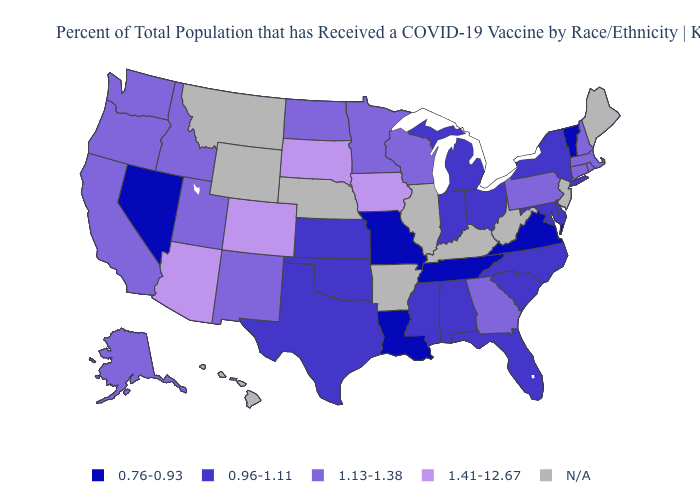Name the states that have a value in the range 1.13-1.38?
Write a very short answer. Alaska, California, Connecticut, Georgia, Idaho, Massachusetts, Minnesota, New Hampshire, New Mexico, North Dakota, Oregon, Pennsylvania, Rhode Island, Utah, Washington, Wisconsin. What is the value of New York?
Keep it brief. 0.96-1.11. Among the states that border South Dakota , which have the lowest value?
Short answer required. Minnesota, North Dakota. Name the states that have a value in the range N/A?
Be succinct. Arkansas, Hawaii, Illinois, Kentucky, Maine, Montana, Nebraska, New Jersey, West Virginia, Wyoming. What is the value of Wyoming?
Quick response, please. N/A. What is the lowest value in states that border West Virginia?
Answer briefly. 0.76-0.93. Among the states that border Tennessee , does Mississippi have the highest value?
Give a very brief answer. No. Name the states that have a value in the range 0.96-1.11?
Answer briefly. Alabama, Delaware, Florida, Indiana, Kansas, Maryland, Michigan, Mississippi, New York, North Carolina, Ohio, Oklahoma, South Carolina, Texas. What is the value of Oregon?
Short answer required. 1.13-1.38. What is the value of Virginia?
Be succinct. 0.76-0.93. How many symbols are there in the legend?
Keep it brief. 5. Among the states that border Ohio , does Pennsylvania have the lowest value?
Be succinct. No. What is the value of New Hampshire?
Write a very short answer. 1.13-1.38. What is the value of Georgia?
Quick response, please. 1.13-1.38. 